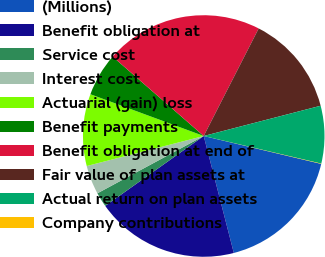Convert chart to OTSL. <chart><loc_0><loc_0><loc_500><loc_500><pie_chart><fcel>(Millions)<fcel>Benefit obligation at<fcel>Service cost<fcel>Interest cost<fcel>Actuarial (gain) loss<fcel>Benefit payments<fcel>Benefit obligation at end of<fcel>Fair value of plan assets at<fcel>Actual return on plan assets<fcel>Company contributions<nl><fcel>17.28%<fcel>19.19%<fcel>1.95%<fcel>3.87%<fcel>9.62%<fcel>5.79%<fcel>21.11%<fcel>13.45%<fcel>7.7%<fcel>0.04%<nl></chart> 